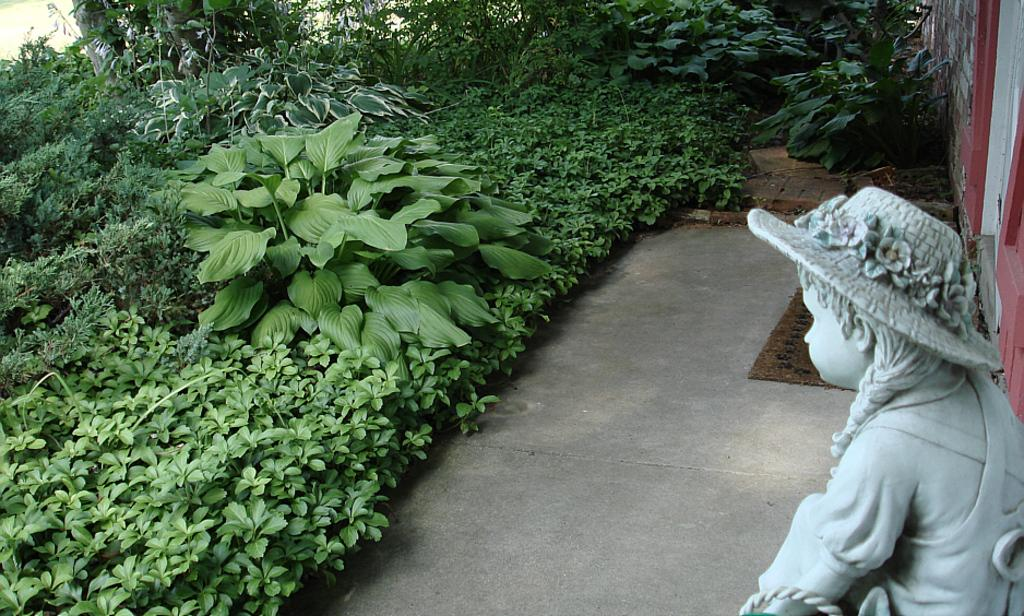What type of living organisms can be seen in the image? Plants can be seen in the image. What is the statue in the image a representation of? The statue in the image is a representation of a person. What type of floor covering is present in the image? There is a floor mat in the image. What type of architectural feature is visible in the image? There is a wall in the image. What type of veil is draped over the statue in the image? There is no veil present in the image; the statue is a representation of a person without any additional coverings. What type of music can be heard playing in the background of the image? There is no music present in the image; it is a still image without any audible elements. 